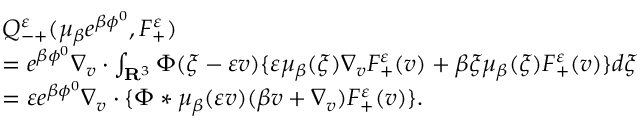<formula> <loc_0><loc_0><loc_500><loc_500>\begin{array} { r l } & { Q _ { - + } ^ { \varepsilon } ( \mu _ { \beta } e ^ { \beta \phi ^ { 0 } } , F _ { + } ^ { \varepsilon } ) } \\ { \quad } & { = e ^ { \beta \phi ^ { 0 } } \nabla _ { v } \cdot \int _ { \mathbf R ^ { 3 } } \Phi ( \xi - \varepsilon v ) \{ \varepsilon \mu _ { \beta } ( \xi ) \nabla _ { v } F _ { + } ^ { \varepsilon } ( v ) + \beta \xi \mu _ { \beta } ( \xi ) F _ { + } ^ { \varepsilon } ( v ) \} d \xi } \\ { \quad } & { = \varepsilon e ^ { \beta \phi ^ { 0 } } \nabla _ { v } \cdot \{ \Phi * \mu _ { \beta } ( \varepsilon v ) ( \beta v + \nabla _ { v } ) F _ { + } ^ { \varepsilon } ( v ) \} . } \end{array}</formula> 